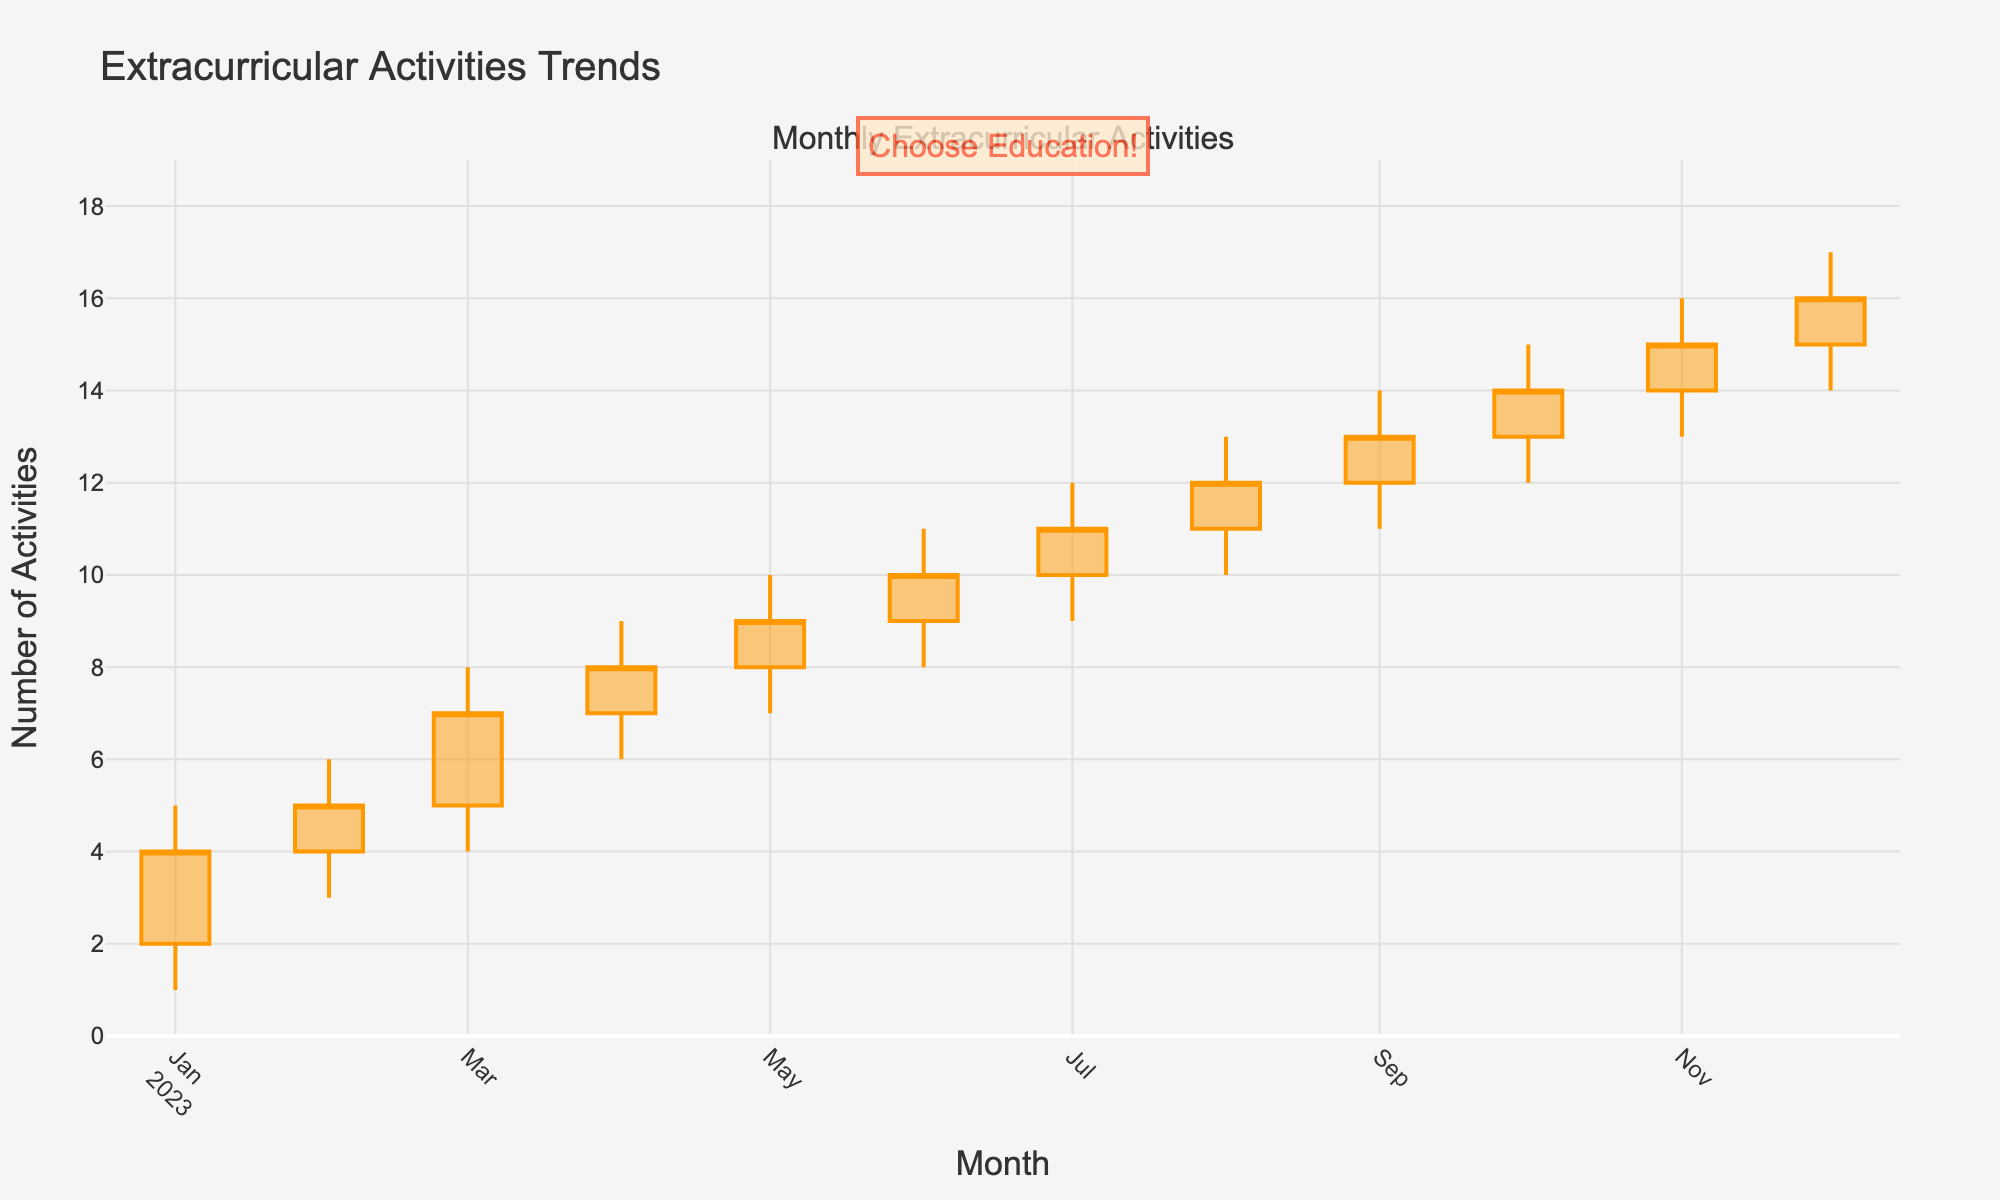What is the title of the plot? The title of the plot is written at the top of the chart. In this case, it reads "Extracurricular Activities Trends."
Answer: Extracurricular Activities Trends Which month shows the highest 'High' value? Look for the month where the upper vertical wick (the 'High' value) of the candlestick reaches the highest point. In this plot, November 2023 has the highest 'High' value at 17.
Answer: November 2023 How many months are represented in the plot? Count the number of candlestick figures, each representing one month, on the x-axis. There are candlesticks from January to December, so there are 12 months.
Answer: 12 Between which two months did the 'Close' value increase the most? To find this, compare the 'Close' values of consecutive months and identify the pair with the largest difference. The largest increase is from January (4) to February (5).
Answer: January to February What was the 'Close' value in June 2023? Look at the closing point of the candlestick for June 2023, which is at the top of the solid part of the candlestick. The 'Close' value is 10.
Answer: 10 Is there any month where the 'Open' value is the same as the 'Close' value? Check each candlestick where the top and bottom of the solid part align, indicating 'Open' and 'Close' values are the same. There is no month where this occurs in the given data.
Answer: No What is the average 'Open' value over the year? Add up all the 'Open' values and divide by the number of months. (2+4+5+7+8+9+10+11+12+13+14+15)/12 = 9
Answer: 9 Which month has the smallest range between 'High' and 'Low' values? Calculate the range ('High' - 'Low') for each month and compare them to find the smallest. January has the smallest range (5 - 1 = 4).
Answer: January How did the 'Close' value change from September to October? Compare the 'Close' values of September (13) and October (14). The 'Close' value increased by 1.
Answer: Increased by 1 Is there an overall upward or downward trend in the 'Close' values through the year? Examine the 'Close' values from January to December. They generally increase each month, indicating an upward trend.
Answer: Upward trend 